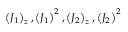Convert formula to latex. <formula><loc_0><loc_0><loc_500><loc_500>\left ( J _ { 1 } \right ) _ { z } , \left ( J _ { 1 } \right ) ^ { 2 } , \left ( J _ { 2 } \right ) _ { z } , \left ( J _ { 2 } \right ) ^ { 2 }</formula> 